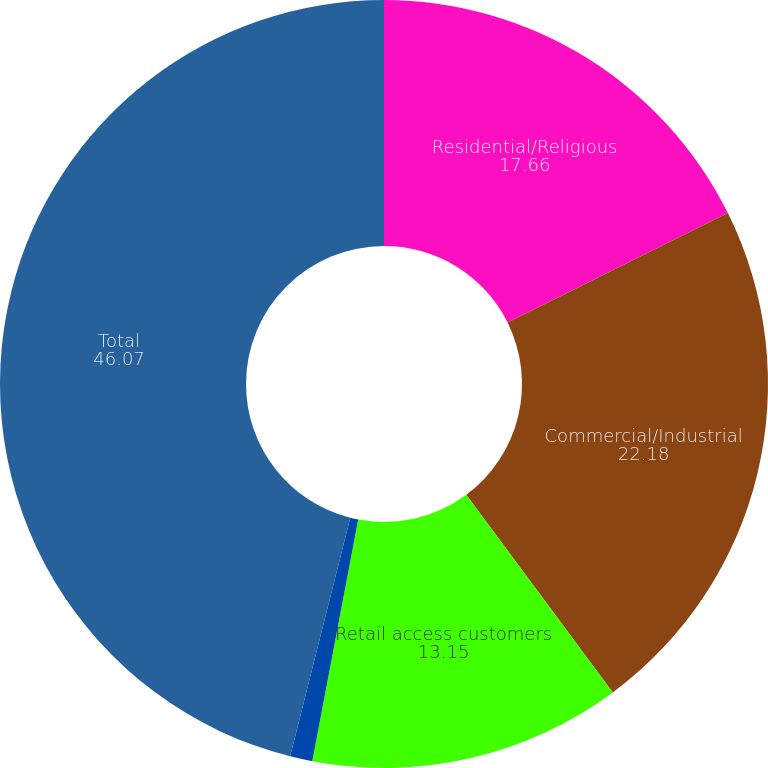Convert chart to OTSL. <chart><loc_0><loc_0><loc_500><loc_500><pie_chart><fcel>Residential/Religious<fcel>Commercial/Industrial<fcel>Retail access customers<fcel>Public authorities<fcel>Total<nl><fcel>17.66%<fcel>22.18%<fcel>13.15%<fcel>0.94%<fcel>46.07%<nl></chart> 